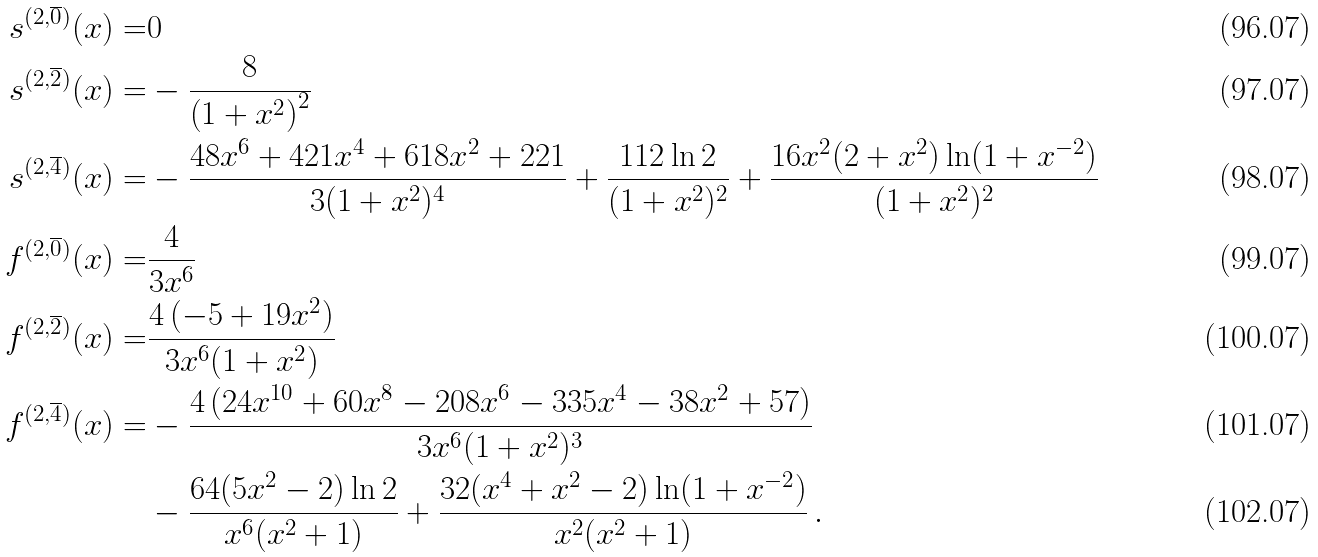Convert formula to latex. <formula><loc_0><loc_0><loc_500><loc_500>s ^ { ( 2 , \overline { 0 } ) } ( x ) = & 0 \\ s ^ { ( 2 , \overline { 2 } ) } ( x ) = & - \frac { 8 } { \left ( 1 + x ^ { 2 } \right ) ^ { 2 } } \\ s ^ { ( 2 , \overline { 4 } ) } ( x ) = & - \frac { 4 8 x ^ { 6 } + 4 2 1 x ^ { 4 } + 6 1 8 x ^ { 2 } + 2 2 1 } { 3 ( 1 + x ^ { 2 } ) ^ { 4 } } + \frac { 1 1 2 \ln 2 } { ( 1 + x ^ { 2 } ) ^ { 2 } } + \frac { 1 6 x ^ { 2 } ( 2 + x ^ { 2 } ) \ln ( 1 + x ^ { - 2 } ) } { ( 1 + x ^ { 2 } ) ^ { 2 } } \\ f ^ { ( 2 , \overline { 0 } ) } ( x ) = & \frac { 4 } { 3 x ^ { 6 } } \\ f ^ { ( 2 , \overline { 2 } ) } ( x ) = & \frac { 4 \left ( - 5 + 1 9 x ^ { 2 } \right ) } { 3 x ^ { 6 } ( 1 + x ^ { 2 } ) } \\ f ^ { ( 2 , \overline { 4 } ) } ( x ) = & - \frac { 4 \left ( 2 4 x ^ { 1 0 } + 6 0 x ^ { 8 } - 2 0 8 x ^ { 6 } - 3 3 5 x ^ { 4 } - 3 8 x ^ { 2 } + 5 7 \right ) } { 3 x ^ { 6 } ( 1 + x ^ { 2 } ) ^ { 3 } } \\ & - \frac { 6 4 ( 5 x ^ { 2 } - 2 ) \ln 2 } { x ^ { 6 } ( x ^ { 2 } + 1 ) } + \frac { 3 2 ( x ^ { 4 } + x ^ { 2 } - 2 ) \ln ( 1 + x ^ { - 2 } ) } { x ^ { 2 } ( x ^ { 2 } + 1 ) } \, .</formula> 